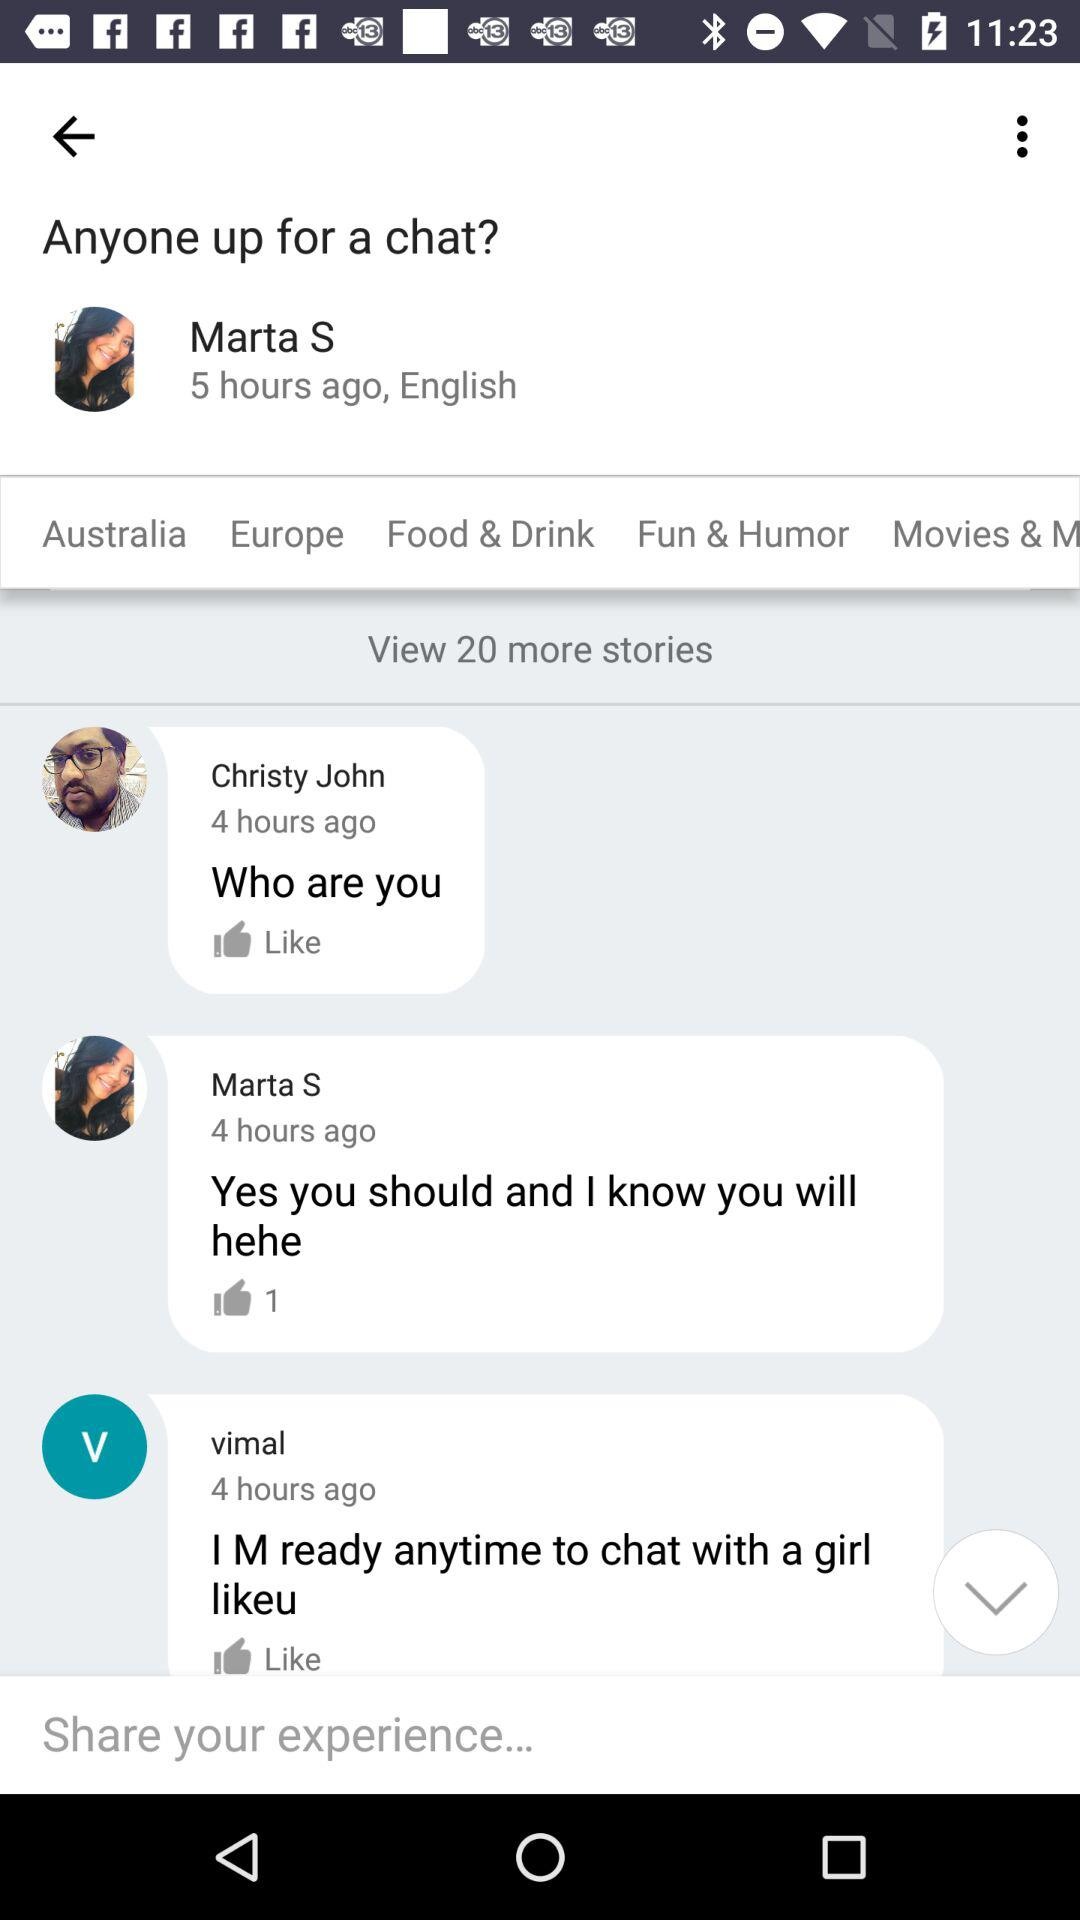What is the user name? The user name is Marta S. 